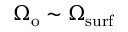<formula> <loc_0><loc_0><loc_500><loc_500>\Omega _ { o } \sim \Omega _ { s u r f }</formula> 